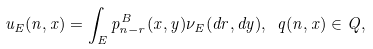Convert formula to latex. <formula><loc_0><loc_0><loc_500><loc_500>u _ { E } ( n , x ) = \int _ { E } p ^ { B } _ { n - r } ( x , y ) \nu _ { E } ( d r , d y ) , \ q ( n , x ) \in Q ,</formula> 